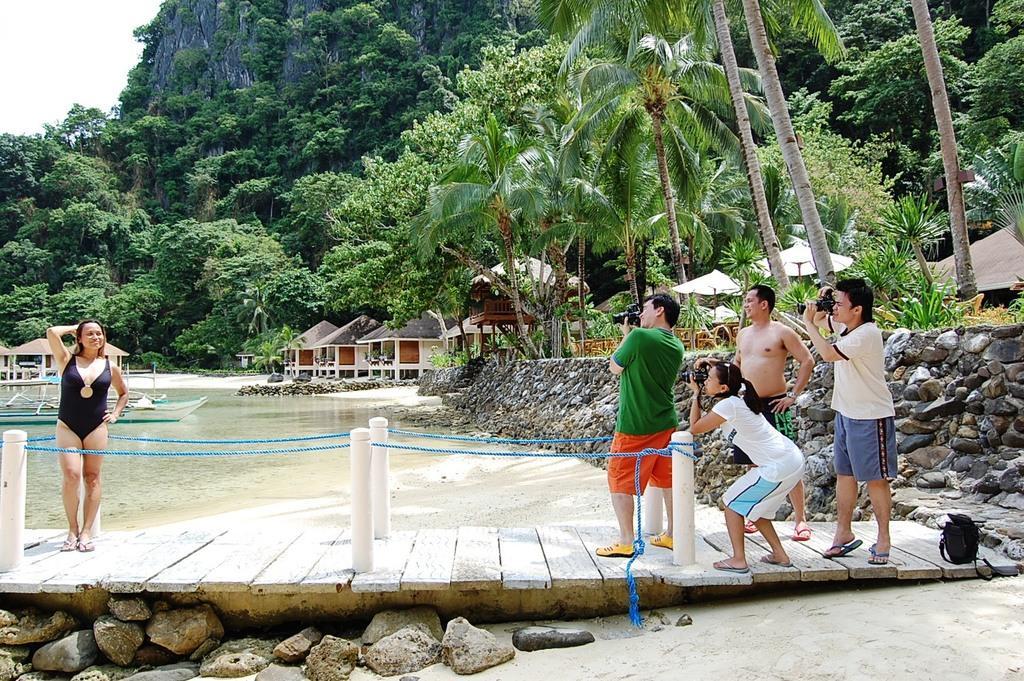Can you describe this image briefly? In this picture there is a woman who is wearing black dress. She is standing on the wooden floor. On the right there is a man who is wearing green t-shirt, red short and yellow shoe. He is holding a camera, beside him there is a girl who is wearing white dress and she is also holding a camera. Besides her there is a man who is wearing a short and sleeper. On the right there is another man who is wearing white t-shirt, blue short and he is holding a camera. Beside him there is a blank bag. At the bottom we can see many stones. In the background we can see the huts and buildings. At the top can see the mountain. On the top right we can see many tree. In the top left corner there is a sky. On the left background we can see the boats on the water. 